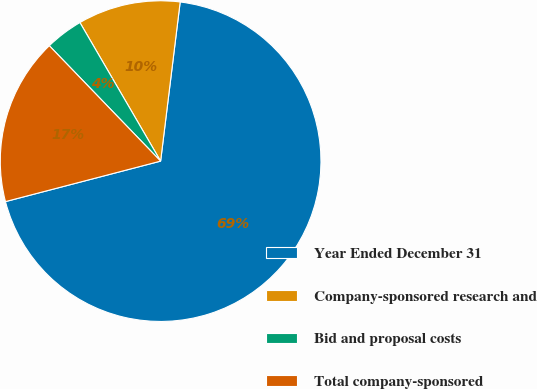Convert chart. <chart><loc_0><loc_0><loc_500><loc_500><pie_chart><fcel>Year Ended December 31<fcel>Company-sponsored research and<fcel>Bid and proposal costs<fcel>Total company-sponsored<nl><fcel>68.99%<fcel>10.34%<fcel>3.82%<fcel>16.85%<nl></chart> 